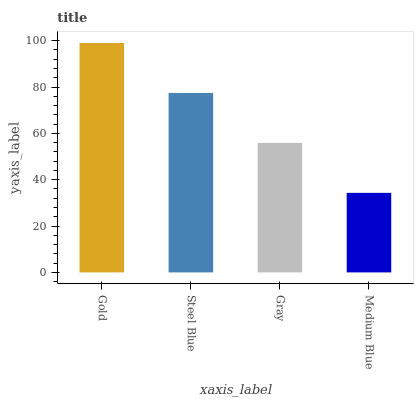Is Medium Blue the minimum?
Answer yes or no. Yes. Is Gold the maximum?
Answer yes or no. Yes. Is Steel Blue the minimum?
Answer yes or no. No. Is Steel Blue the maximum?
Answer yes or no. No. Is Gold greater than Steel Blue?
Answer yes or no. Yes. Is Steel Blue less than Gold?
Answer yes or no. Yes. Is Steel Blue greater than Gold?
Answer yes or no. No. Is Gold less than Steel Blue?
Answer yes or no. No. Is Steel Blue the high median?
Answer yes or no. Yes. Is Gray the low median?
Answer yes or no. Yes. Is Gray the high median?
Answer yes or no. No. Is Steel Blue the low median?
Answer yes or no. No. 